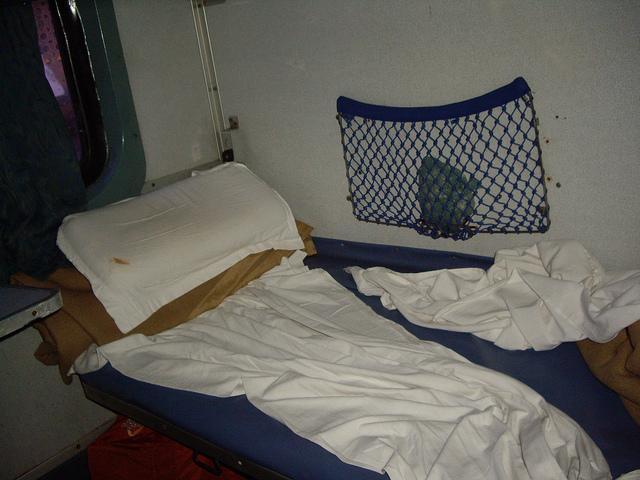How many people are shown?
Give a very brief answer. 0. 